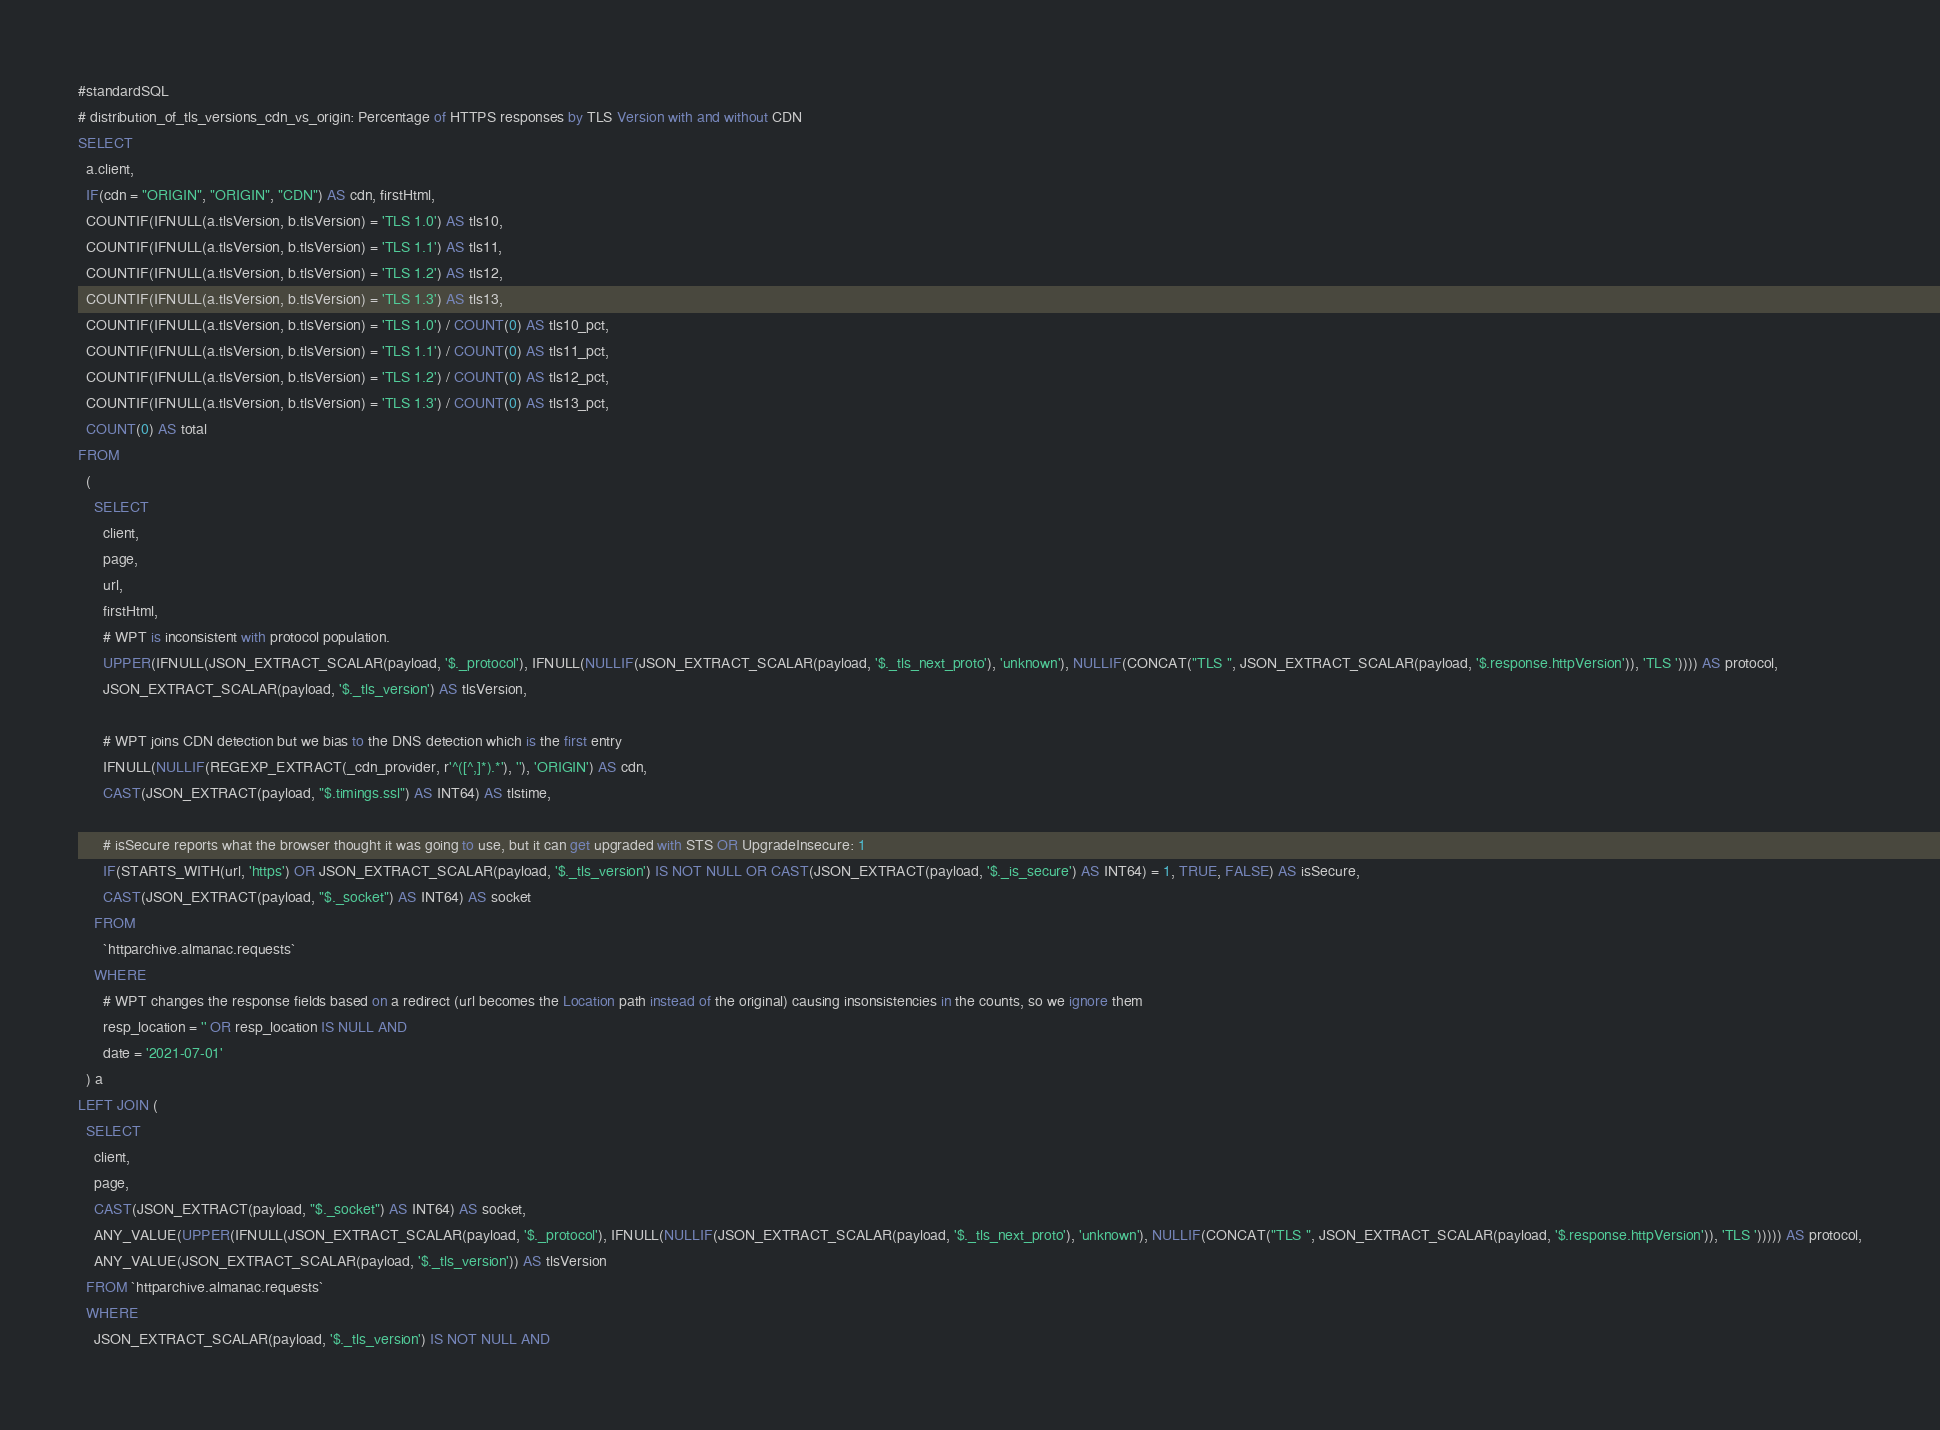<code> <loc_0><loc_0><loc_500><loc_500><_SQL_>#standardSQL
# distribution_of_tls_versions_cdn_vs_origin: Percentage of HTTPS responses by TLS Version with and without CDN
SELECT
  a.client,
  IF(cdn = "ORIGIN", "ORIGIN", "CDN") AS cdn, firstHtml,
  COUNTIF(IFNULL(a.tlsVersion, b.tlsVersion) = 'TLS 1.0') AS tls10,
  COUNTIF(IFNULL(a.tlsVersion, b.tlsVersion) = 'TLS 1.1') AS tls11,
  COUNTIF(IFNULL(a.tlsVersion, b.tlsVersion) = 'TLS 1.2') AS tls12,
  COUNTIF(IFNULL(a.tlsVersion, b.tlsVersion) = 'TLS 1.3') AS tls13,
  COUNTIF(IFNULL(a.tlsVersion, b.tlsVersion) = 'TLS 1.0') / COUNT(0) AS tls10_pct,
  COUNTIF(IFNULL(a.tlsVersion, b.tlsVersion) = 'TLS 1.1') / COUNT(0) AS tls11_pct,
  COUNTIF(IFNULL(a.tlsVersion, b.tlsVersion) = 'TLS 1.2') / COUNT(0) AS tls12_pct,
  COUNTIF(IFNULL(a.tlsVersion, b.tlsVersion) = 'TLS 1.3') / COUNT(0) AS tls13_pct,
  COUNT(0) AS total
FROM
  (
    SELECT
      client,
      page,
      url,
      firstHtml,
      # WPT is inconsistent with protocol population.
      UPPER(IFNULL(JSON_EXTRACT_SCALAR(payload, '$._protocol'), IFNULL(NULLIF(JSON_EXTRACT_SCALAR(payload, '$._tls_next_proto'), 'unknown'), NULLIF(CONCAT("TLS ", JSON_EXTRACT_SCALAR(payload, '$.response.httpVersion')), 'TLS ')))) AS protocol,
      JSON_EXTRACT_SCALAR(payload, '$._tls_version') AS tlsVersion,

      # WPT joins CDN detection but we bias to the DNS detection which is the first entry
      IFNULL(NULLIF(REGEXP_EXTRACT(_cdn_provider, r'^([^,]*).*'), ''), 'ORIGIN') AS cdn,
      CAST(JSON_EXTRACT(payload, "$.timings.ssl") AS INT64) AS tlstime,

      # isSecure reports what the browser thought it was going to use, but it can get upgraded with STS OR UpgradeInsecure: 1
      IF(STARTS_WITH(url, 'https') OR JSON_EXTRACT_SCALAR(payload, '$._tls_version') IS NOT NULL OR CAST(JSON_EXTRACT(payload, '$._is_secure') AS INT64) = 1, TRUE, FALSE) AS isSecure,
      CAST(JSON_EXTRACT(payload, "$._socket") AS INT64) AS socket
    FROM
      `httparchive.almanac.requests`
    WHERE
      # WPT changes the response fields based on a redirect (url becomes the Location path instead of the original) causing insonsistencies in the counts, so we ignore them
      resp_location = '' OR resp_location IS NULL AND
      date = '2021-07-01'
  ) a
LEFT JOIN (
  SELECT
    client,
    page,
    CAST(JSON_EXTRACT(payload, "$._socket") AS INT64) AS socket,
    ANY_VALUE(UPPER(IFNULL(JSON_EXTRACT_SCALAR(payload, '$._protocol'), IFNULL(NULLIF(JSON_EXTRACT_SCALAR(payload, '$._tls_next_proto'), 'unknown'), NULLIF(CONCAT("TLS ", JSON_EXTRACT_SCALAR(payload, '$.response.httpVersion')), 'TLS '))))) AS protocol,
    ANY_VALUE(JSON_EXTRACT_SCALAR(payload, '$._tls_version')) AS tlsVersion
  FROM `httparchive.almanac.requests`
  WHERE
    JSON_EXTRACT_SCALAR(payload, '$._tls_version') IS NOT NULL AND</code> 